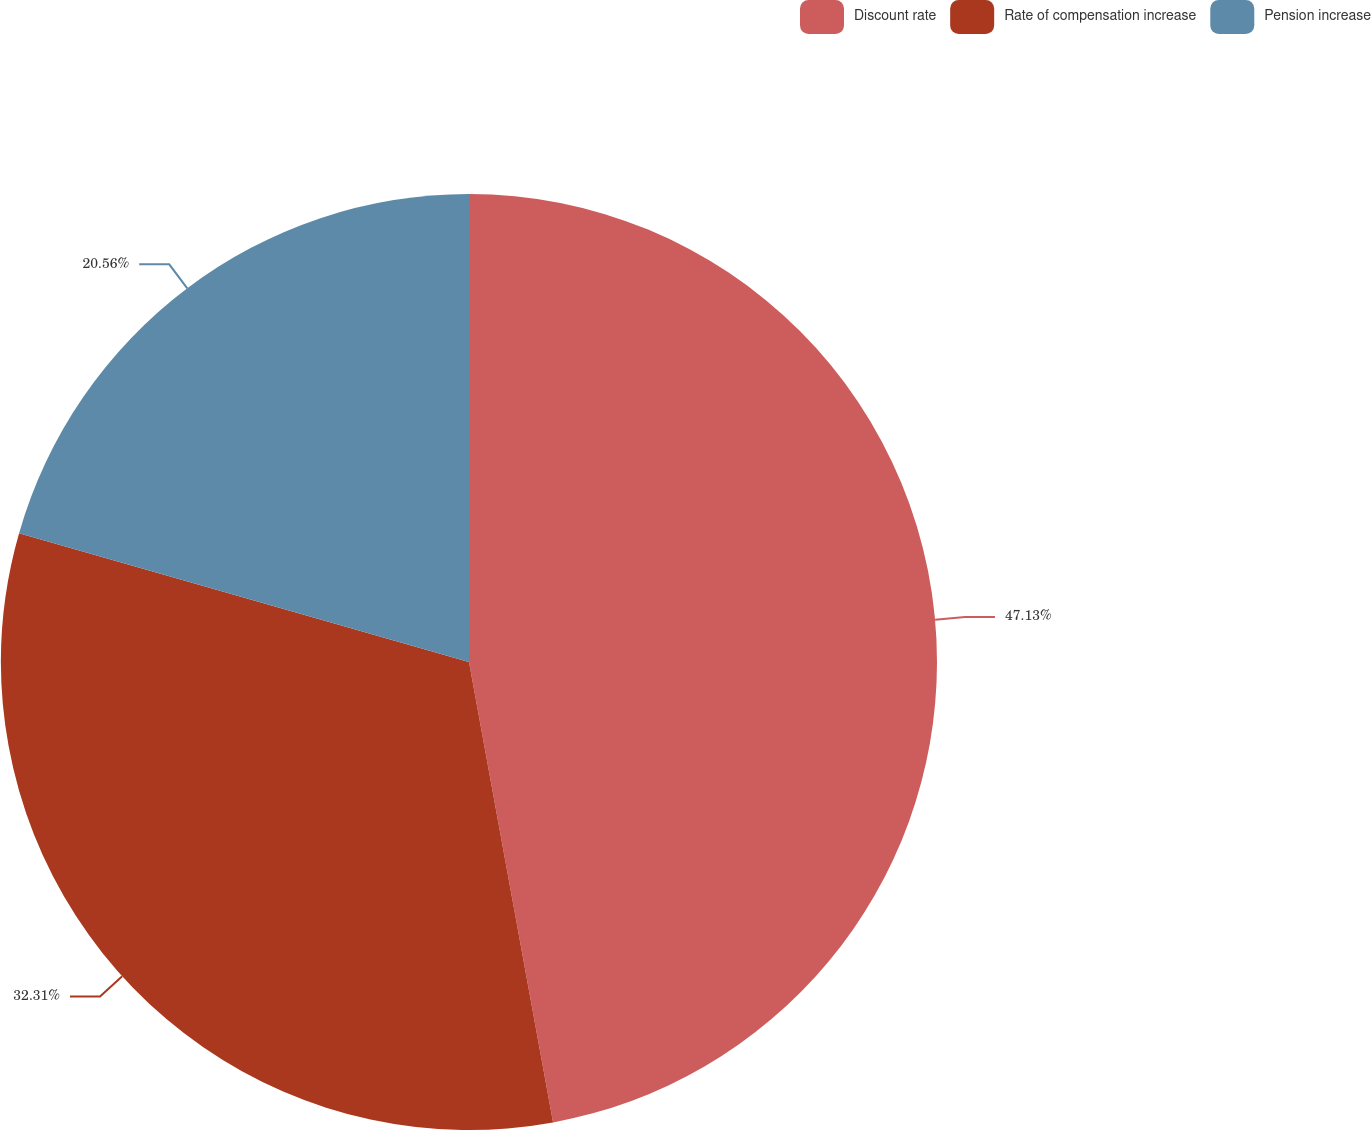Convert chart to OTSL. <chart><loc_0><loc_0><loc_500><loc_500><pie_chart><fcel>Discount rate<fcel>Rate of compensation increase<fcel>Pension increase<nl><fcel>47.12%<fcel>32.31%<fcel>20.56%<nl></chart> 